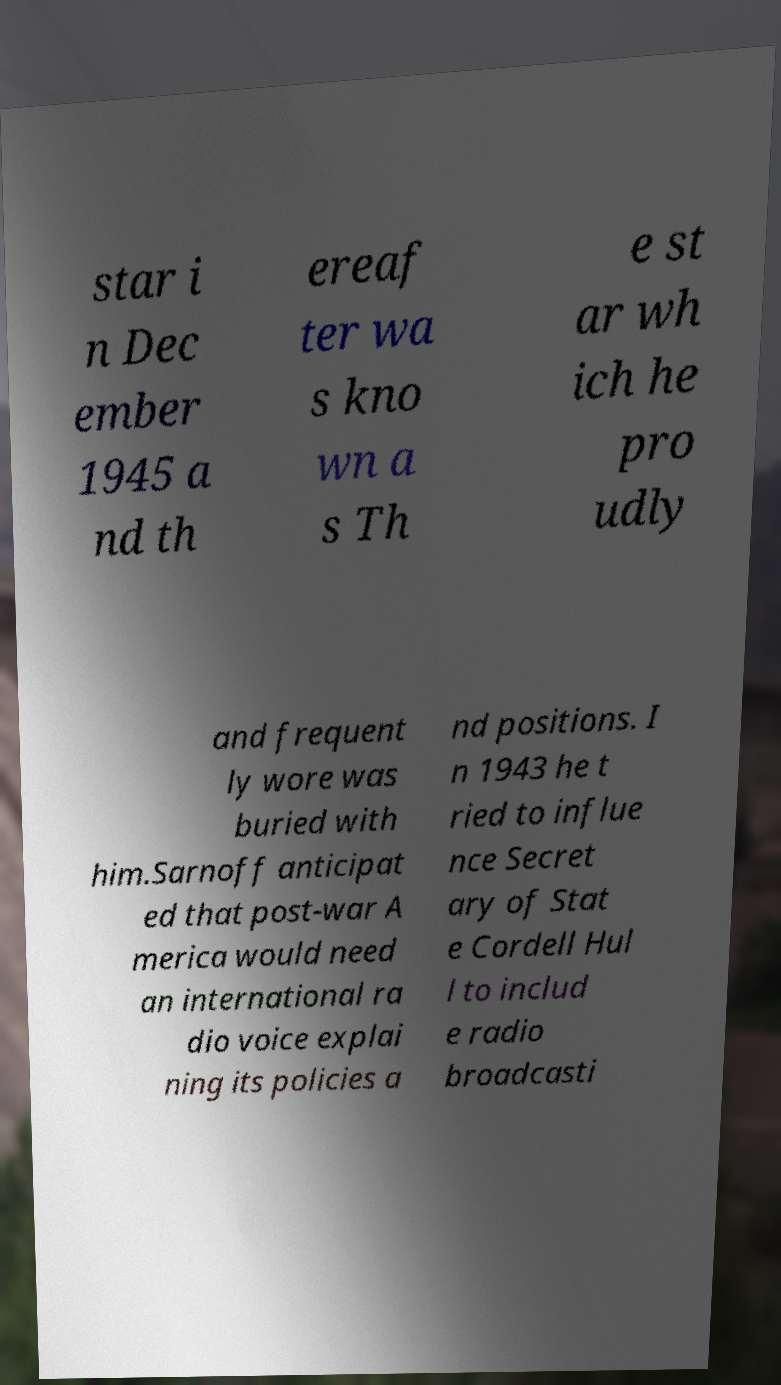For documentation purposes, I need the text within this image transcribed. Could you provide that? star i n Dec ember 1945 a nd th ereaf ter wa s kno wn a s Th e st ar wh ich he pro udly and frequent ly wore was buried with him.Sarnoff anticipat ed that post-war A merica would need an international ra dio voice explai ning its policies a nd positions. I n 1943 he t ried to influe nce Secret ary of Stat e Cordell Hul l to includ e radio broadcasti 